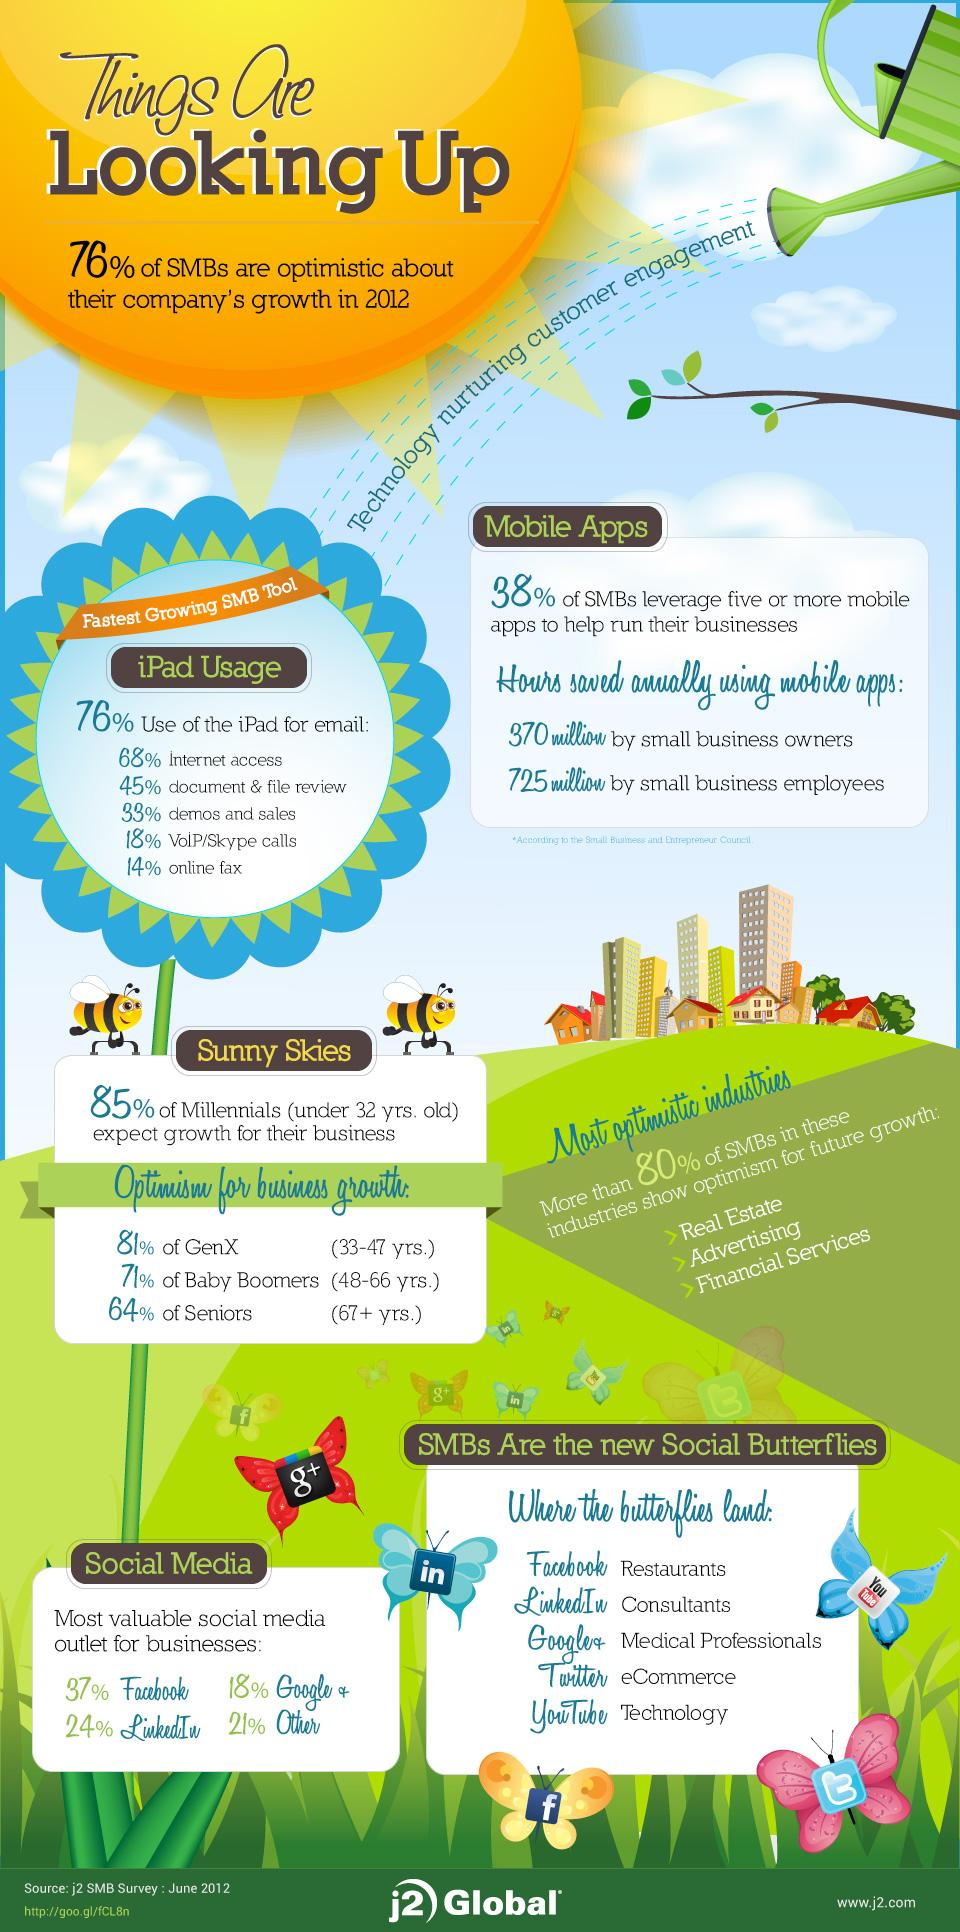Outline some significant characteristics in this image. According to a recent study, only 19% of SMBs use Facebook for their business, while Google+ is not used at all by any of them. According to research, a small percentage of small and medium-sized businesses (SMBs) prefer to use LinkedIn over other social media tools, with 3% being the estimated figure. 